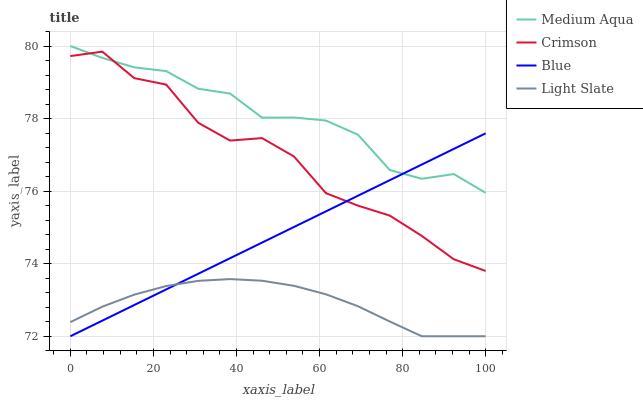Does Light Slate have the minimum area under the curve?
Answer yes or no. Yes. Does Medium Aqua have the maximum area under the curve?
Answer yes or no. Yes. Does Blue have the minimum area under the curve?
Answer yes or no. No. Does Blue have the maximum area under the curve?
Answer yes or no. No. Is Blue the smoothest?
Answer yes or no. Yes. Is Crimson the roughest?
Answer yes or no. Yes. Is Medium Aqua the smoothest?
Answer yes or no. No. Is Medium Aqua the roughest?
Answer yes or no. No. Does Blue have the lowest value?
Answer yes or no. Yes. Does Medium Aqua have the lowest value?
Answer yes or no. No. Does Medium Aqua have the highest value?
Answer yes or no. Yes. Does Blue have the highest value?
Answer yes or no. No. Is Light Slate less than Crimson?
Answer yes or no. Yes. Is Medium Aqua greater than Light Slate?
Answer yes or no. Yes. Does Blue intersect Medium Aqua?
Answer yes or no. Yes. Is Blue less than Medium Aqua?
Answer yes or no. No. Is Blue greater than Medium Aqua?
Answer yes or no. No. Does Light Slate intersect Crimson?
Answer yes or no. No. 